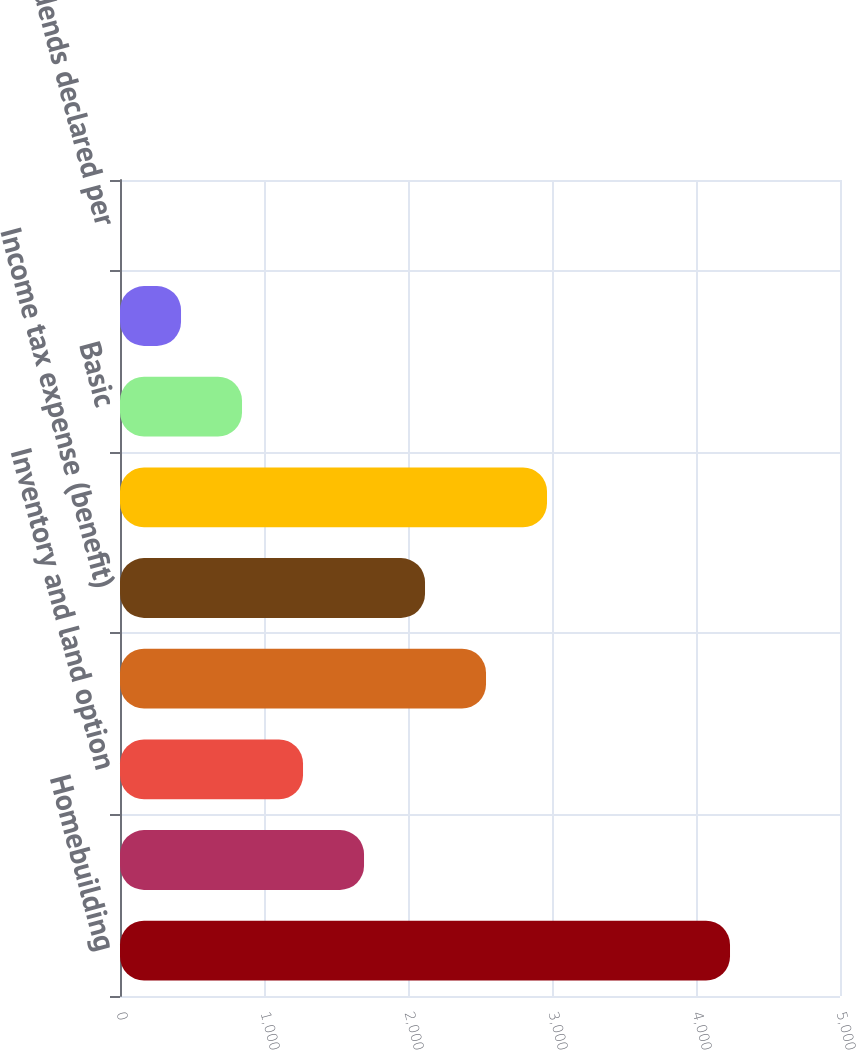Convert chart to OTSL. <chart><loc_0><loc_0><loc_500><loc_500><bar_chart><fcel>Homebuilding<fcel>Financial Services<fcel>Inventory and land option<fcel>Gross profit - Homebuilding<fcel>Income tax expense (benefit)<fcel>Net income<fcel>Basic<fcel>Diluted<fcel>Cash dividends declared per<nl><fcel>4236.2<fcel>1694.58<fcel>1270.97<fcel>2541.78<fcel>2118.18<fcel>2965.39<fcel>847.36<fcel>423.75<fcel>0.15<nl></chart> 